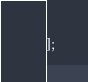Convert code to text. <code><loc_0><loc_0><loc_500><loc_500><_JavaScript_>];</code> 